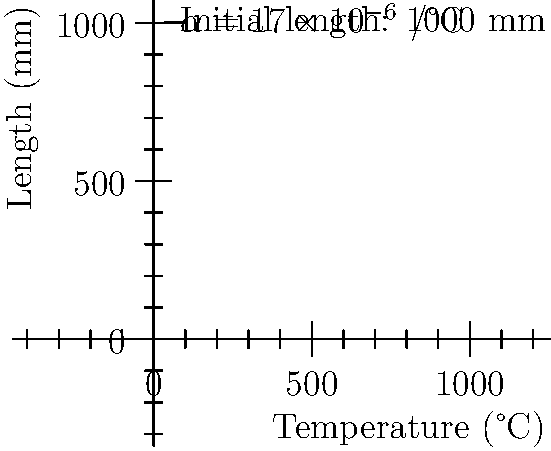A steel rod used in a critical component of a bridge has an initial length of 1000 mm at 0°C. Given that the coefficient of linear thermal expansion for steel is $17 \times 10^{-6}$ /°C, calculate the change in length of the rod when the temperature increases to 80°C. How might this expansion affect the bridge's structural integrity? To solve this problem, we'll use the linear thermal expansion equation and follow these steps:

1) The linear thermal expansion equation is:
   $\Delta L = \alpha L_0 \Delta T$

   Where:
   $\Delta L$ = change in length
   $\alpha$ = coefficient of linear thermal expansion
   $L_0$ = initial length
   $\Delta T$ = change in temperature

2) Given values:
   $\alpha = 17 \times 10^{-6}$ /°C
   $L_0 = 1000$ mm
   $\Delta T = 80°C - 0°C = 80°C$

3) Substituting these values into the equation:
   $\Delta L = (17 \times 10^{-6})(1000)(80)$

4) Calculating:
   $\Delta L = 1.36$ mm

5) Regarding the bridge's structural integrity:
   This expansion, although small, could cause stress in connected components if not accounted for in the design. It might lead to buckling or misalignment in extreme cases. However, most bridge designs incorporate expansion joints to accommodate such thermal expansions, ensuring the structure's safety and longevity.
Answer: $1.36$ mm expansion; potential stress on connected components if not accommodated in design. 